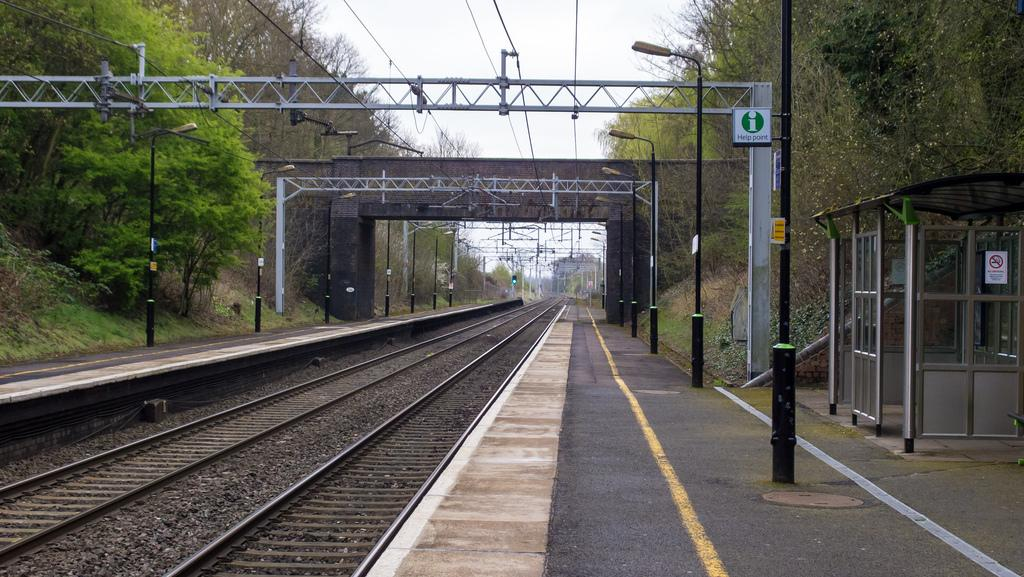What type of vegetation can be seen on the left side of the image? There are trees on the left side of the image. What type of vegetation can be seen on the right side of the image? There are trees on the right side of the image. What type of transportation infrastructure is visible at the bottom of the image? Railway tracks are visible at the bottom of the image. What type of electrical infrastructure is present at the top of the image? Current wires are present at the top of the image. What type of reading material can be seen in the image? There is no reading material present in the image. 